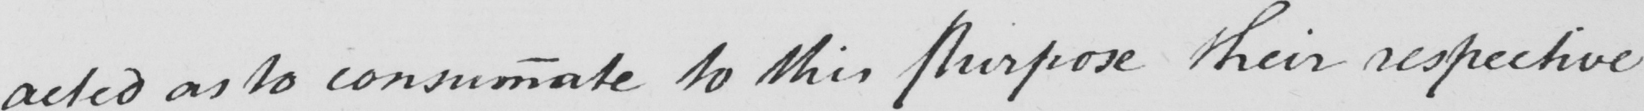What does this handwritten line say? acted as to consummate to this Purpose their respective 